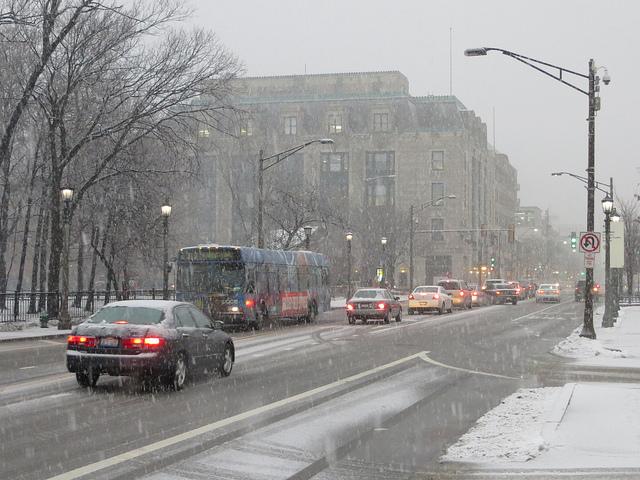How many care do you see?
Write a very short answer. 9. What is the white stuff falling from the sky?
Short answer required. Snow. Do all the vehicles have their lights on?
Keep it brief. Yes. What is the weather like?
Give a very brief answer. Snowy. How many green lights are there?
Quick response, please. 2. Who are at the sidewalks?
Write a very short answer. No one. 